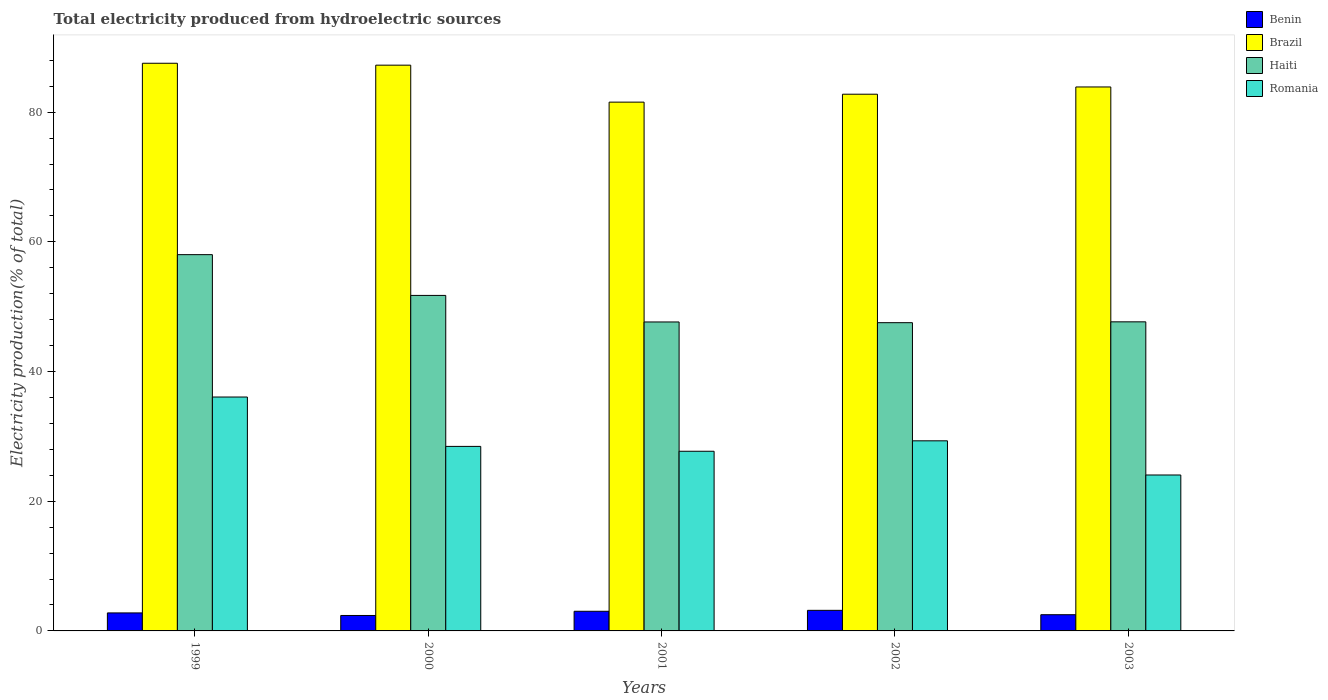How many different coloured bars are there?
Your answer should be very brief. 4. How many groups of bars are there?
Provide a succinct answer. 5. How many bars are there on the 1st tick from the left?
Ensure brevity in your answer.  4. How many bars are there on the 2nd tick from the right?
Offer a terse response. 4. What is the label of the 5th group of bars from the left?
Provide a succinct answer. 2003. In how many cases, is the number of bars for a given year not equal to the number of legend labels?
Provide a short and direct response. 0. What is the total electricity produced in Haiti in 1999?
Give a very brief answer. 58.02. Across all years, what is the maximum total electricity produced in Brazil?
Give a very brief answer. 87.54. Across all years, what is the minimum total electricity produced in Benin?
Keep it short and to the point. 2.38. In which year was the total electricity produced in Brazil maximum?
Keep it short and to the point. 1999. What is the total total electricity produced in Benin in the graph?
Offer a terse response. 13.86. What is the difference between the total electricity produced in Benin in 2001 and that in 2002?
Your answer should be very brief. -0.14. What is the difference between the total electricity produced in Brazil in 2003 and the total electricity produced in Romania in 1999?
Your answer should be very brief. 47.81. What is the average total electricity produced in Haiti per year?
Offer a terse response. 50.52. In the year 2001, what is the difference between the total electricity produced in Romania and total electricity produced in Haiti?
Offer a very short reply. -19.94. What is the ratio of the total electricity produced in Romania in 1999 to that in 2003?
Provide a succinct answer. 1.5. Is the total electricity produced in Benin in 2001 less than that in 2003?
Ensure brevity in your answer.  No. Is the difference between the total electricity produced in Romania in 2001 and 2002 greater than the difference between the total electricity produced in Haiti in 2001 and 2002?
Keep it short and to the point. No. What is the difference between the highest and the second highest total electricity produced in Romania?
Your answer should be compact. 6.75. What is the difference between the highest and the lowest total electricity produced in Brazil?
Provide a short and direct response. 5.99. In how many years, is the total electricity produced in Haiti greater than the average total electricity produced in Haiti taken over all years?
Give a very brief answer. 2. Is the sum of the total electricity produced in Benin in 1999 and 2002 greater than the maximum total electricity produced in Haiti across all years?
Your answer should be compact. No. What does the 2nd bar from the left in 2001 represents?
Make the answer very short. Brazil. What does the 1st bar from the right in 2002 represents?
Provide a succinct answer. Romania. Is it the case that in every year, the sum of the total electricity produced in Benin and total electricity produced in Haiti is greater than the total electricity produced in Romania?
Your answer should be very brief. Yes. How many years are there in the graph?
Your answer should be very brief. 5. Does the graph contain any zero values?
Make the answer very short. No. Where does the legend appear in the graph?
Offer a very short reply. Top right. How are the legend labels stacked?
Your answer should be compact. Vertical. What is the title of the graph?
Your answer should be compact. Total electricity produced from hydroelectric sources. What is the Electricity production(% of total) of Benin in 1999?
Give a very brief answer. 2.78. What is the Electricity production(% of total) in Brazil in 1999?
Your response must be concise. 87.54. What is the Electricity production(% of total) in Haiti in 1999?
Your answer should be very brief. 58.02. What is the Electricity production(% of total) in Romania in 1999?
Ensure brevity in your answer.  36.07. What is the Electricity production(% of total) in Benin in 2000?
Make the answer very short. 2.38. What is the Electricity production(% of total) of Brazil in 2000?
Ensure brevity in your answer.  87.24. What is the Electricity production(% of total) in Haiti in 2000?
Offer a terse response. 51.74. What is the Electricity production(% of total) in Romania in 2000?
Give a very brief answer. 28.46. What is the Electricity production(% of total) of Benin in 2001?
Make the answer very short. 3.03. What is the Electricity production(% of total) in Brazil in 2001?
Your answer should be very brief. 81.54. What is the Electricity production(% of total) of Haiti in 2001?
Offer a very short reply. 47.64. What is the Electricity production(% of total) of Romania in 2001?
Your answer should be very brief. 27.7. What is the Electricity production(% of total) of Benin in 2002?
Your answer should be very brief. 3.17. What is the Electricity production(% of total) of Brazil in 2002?
Your answer should be very brief. 82.76. What is the Electricity production(% of total) of Haiti in 2002?
Provide a short and direct response. 47.53. What is the Electricity production(% of total) in Romania in 2002?
Provide a succinct answer. 29.32. What is the Electricity production(% of total) in Benin in 2003?
Make the answer very short. 2.5. What is the Electricity production(% of total) in Brazil in 2003?
Your response must be concise. 83.88. What is the Electricity production(% of total) in Haiti in 2003?
Offer a terse response. 47.66. What is the Electricity production(% of total) of Romania in 2003?
Make the answer very short. 24.05. Across all years, what is the maximum Electricity production(% of total) of Benin?
Offer a terse response. 3.17. Across all years, what is the maximum Electricity production(% of total) of Brazil?
Ensure brevity in your answer.  87.54. Across all years, what is the maximum Electricity production(% of total) of Haiti?
Ensure brevity in your answer.  58.02. Across all years, what is the maximum Electricity production(% of total) of Romania?
Keep it short and to the point. 36.07. Across all years, what is the minimum Electricity production(% of total) of Benin?
Ensure brevity in your answer.  2.38. Across all years, what is the minimum Electricity production(% of total) of Brazil?
Keep it short and to the point. 81.54. Across all years, what is the minimum Electricity production(% of total) in Haiti?
Make the answer very short. 47.53. Across all years, what is the minimum Electricity production(% of total) in Romania?
Ensure brevity in your answer.  24.05. What is the total Electricity production(% of total) of Benin in the graph?
Offer a terse response. 13.86. What is the total Electricity production(% of total) in Brazil in the graph?
Your response must be concise. 422.97. What is the total Electricity production(% of total) in Haiti in the graph?
Provide a short and direct response. 252.6. What is the total Electricity production(% of total) of Romania in the graph?
Give a very brief answer. 145.59. What is the difference between the Electricity production(% of total) of Benin in 1999 and that in 2000?
Offer a terse response. 0.4. What is the difference between the Electricity production(% of total) in Brazil in 1999 and that in 2000?
Your answer should be compact. 0.29. What is the difference between the Electricity production(% of total) in Haiti in 1999 and that in 2000?
Offer a terse response. 6.29. What is the difference between the Electricity production(% of total) of Romania in 1999 and that in 2000?
Offer a very short reply. 7.61. What is the difference between the Electricity production(% of total) in Benin in 1999 and that in 2001?
Provide a short and direct response. -0.25. What is the difference between the Electricity production(% of total) in Brazil in 1999 and that in 2001?
Provide a short and direct response. 5.99. What is the difference between the Electricity production(% of total) of Haiti in 1999 and that in 2001?
Offer a very short reply. 10.38. What is the difference between the Electricity production(% of total) in Romania in 1999 and that in 2001?
Your answer should be compact. 8.36. What is the difference between the Electricity production(% of total) in Benin in 1999 and that in 2002?
Your answer should be compact. -0.4. What is the difference between the Electricity production(% of total) of Brazil in 1999 and that in 2002?
Your answer should be very brief. 4.77. What is the difference between the Electricity production(% of total) of Haiti in 1999 and that in 2002?
Make the answer very short. 10.49. What is the difference between the Electricity production(% of total) of Romania in 1999 and that in 2002?
Give a very brief answer. 6.75. What is the difference between the Electricity production(% of total) in Benin in 1999 and that in 2003?
Offer a terse response. 0.28. What is the difference between the Electricity production(% of total) of Brazil in 1999 and that in 2003?
Offer a terse response. 3.65. What is the difference between the Electricity production(% of total) of Haiti in 1999 and that in 2003?
Ensure brevity in your answer.  10.36. What is the difference between the Electricity production(% of total) in Romania in 1999 and that in 2003?
Provide a succinct answer. 12.02. What is the difference between the Electricity production(% of total) in Benin in 2000 and that in 2001?
Provide a succinct answer. -0.65. What is the difference between the Electricity production(% of total) of Brazil in 2000 and that in 2001?
Offer a very short reply. 5.7. What is the difference between the Electricity production(% of total) of Haiti in 2000 and that in 2001?
Give a very brief answer. 4.09. What is the difference between the Electricity production(% of total) in Romania in 2000 and that in 2001?
Keep it short and to the point. 0.75. What is the difference between the Electricity production(% of total) of Benin in 2000 and that in 2002?
Provide a short and direct response. -0.79. What is the difference between the Electricity production(% of total) of Brazil in 2000 and that in 2002?
Ensure brevity in your answer.  4.48. What is the difference between the Electricity production(% of total) of Haiti in 2000 and that in 2002?
Your response must be concise. 4.2. What is the difference between the Electricity production(% of total) of Romania in 2000 and that in 2002?
Your answer should be compact. -0.86. What is the difference between the Electricity production(% of total) of Benin in 2000 and that in 2003?
Your response must be concise. -0.12. What is the difference between the Electricity production(% of total) of Brazil in 2000 and that in 2003?
Ensure brevity in your answer.  3.36. What is the difference between the Electricity production(% of total) of Haiti in 2000 and that in 2003?
Offer a very short reply. 4.07. What is the difference between the Electricity production(% of total) in Romania in 2000 and that in 2003?
Give a very brief answer. 4.41. What is the difference between the Electricity production(% of total) in Benin in 2001 and that in 2002?
Your response must be concise. -0.14. What is the difference between the Electricity production(% of total) of Brazil in 2001 and that in 2002?
Your answer should be compact. -1.22. What is the difference between the Electricity production(% of total) of Romania in 2001 and that in 2002?
Your response must be concise. -1.61. What is the difference between the Electricity production(% of total) of Benin in 2001 and that in 2003?
Your answer should be compact. 0.53. What is the difference between the Electricity production(% of total) in Brazil in 2001 and that in 2003?
Make the answer very short. -2.34. What is the difference between the Electricity production(% of total) in Haiti in 2001 and that in 2003?
Keep it short and to the point. -0.02. What is the difference between the Electricity production(% of total) of Romania in 2001 and that in 2003?
Your response must be concise. 3.66. What is the difference between the Electricity production(% of total) in Benin in 2002 and that in 2003?
Your answer should be very brief. 0.67. What is the difference between the Electricity production(% of total) in Brazil in 2002 and that in 2003?
Offer a very short reply. -1.12. What is the difference between the Electricity production(% of total) in Haiti in 2002 and that in 2003?
Offer a terse response. -0.13. What is the difference between the Electricity production(% of total) of Romania in 2002 and that in 2003?
Offer a very short reply. 5.27. What is the difference between the Electricity production(% of total) in Benin in 1999 and the Electricity production(% of total) in Brazil in 2000?
Provide a short and direct response. -84.47. What is the difference between the Electricity production(% of total) of Benin in 1999 and the Electricity production(% of total) of Haiti in 2000?
Keep it short and to the point. -48.96. What is the difference between the Electricity production(% of total) in Benin in 1999 and the Electricity production(% of total) in Romania in 2000?
Your response must be concise. -25.68. What is the difference between the Electricity production(% of total) in Brazil in 1999 and the Electricity production(% of total) in Haiti in 2000?
Give a very brief answer. 35.8. What is the difference between the Electricity production(% of total) of Brazil in 1999 and the Electricity production(% of total) of Romania in 2000?
Keep it short and to the point. 59.08. What is the difference between the Electricity production(% of total) of Haiti in 1999 and the Electricity production(% of total) of Romania in 2000?
Your response must be concise. 29.57. What is the difference between the Electricity production(% of total) of Benin in 1999 and the Electricity production(% of total) of Brazil in 2001?
Keep it short and to the point. -78.77. What is the difference between the Electricity production(% of total) of Benin in 1999 and the Electricity production(% of total) of Haiti in 2001?
Offer a terse response. -44.87. What is the difference between the Electricity production(% of total) in Benin in 1999 and the Electricity production(% of total) in Romania in 2001?
Offer a very short reply. -24.93. What is the difference between the Electricity production(% of total) of Brazil in 1999 and the Electricity production(% of total) of Haiti in 2001?
Provide a succinct answer. 39.89. What is the difference between the Electricity production(% of total) of Brazil in 1999 and the Electricity production(% of total) of Romania in 2001?
Keep it short and to the point. 59.83. What is the difference between the Electricity production(% of total) in Haiti in 1999 and the Electricity production(% of total) in Romania in 2001?
Provide a short and direct response. 30.32. What is the difference between the Electricity production(% of total) of Benin in 1999 and the Electricity production(% of total) of Brazil in 2002?
Offer a terse response. -79.99. What is the difference between the Electricity production(% of total) in Benin in 1999 and the Electricity production(% of total) in Haiti in 2002?
Give a very brief answer. -44.75. What is the difference between the Electricity production(% of total) in Benin in 1999 and the Electricity production(% of total) in Romania in 2002?
Offer a very short reply. -26.54. What is the difference between the Electricity production(% of total) of Brazil in 1999 and the Electricity production(% of total) of Haiti in 2002?
Make the answer very short. 40. What is the difference between the Electricity production(% of total) in Brazil in 1999 and the Electricity production(% of total) in Romania in 2002?
Offer a very short reply. 58.22. What is the difference between the Electricity production(% of total) of Haiti in 1999 and the Electricity production(% of total) of Romania in 2002?
Your response must be concise. 28.71. What is the difference between the Electricity production(% of total) of Benin in 1999 and the Electricity production(% of total) of Brazil in 2003?
Give a very brief answer. -81.1. What is the difference between the Electricity production(% of total) of Benin in 1999 and the Electricity production(% of total) of Haiti in 2003?
Give a very brief answer. -44.89. What is the difference between the Electricity production(% of total) in Benin in 1999 and the Electricity production(% of total) in Romania in 2003?
Your answer should be compact. -21.27. What is the difference between the Electricity production(% of total) in Brazil in 1999 and the Electricity production(% of total) in Haiti in 2003?
Your answer should be compact. 39.87. What is the difference between the Electricity production(% of total) in Brazil in 1999 and the Electricity production(% of total) in Romania in 2003?
Your answer should be very brief. 63.49. What is the difference between the Electricity production(% of total) in Haiti in 1999 and the Electricity production(% of total) in Romania in 2003?
Give a very brief answer. 33.98. What is the difference between the Electricity production(% of total) in Benin in 2000 and the Electricity production(% of total) in Brazil in 2001?
Provide a succinct answer. -79.16. What is the difference between the Electricity production(% of total) in Benin in 2000 and the Electricity production(% of total) in Haiti in 2001?
Offer a very short reply. -45.26. What is the difference between the Electricity production(% of total) in Benin in 2000 and the Electricity production(% of total) in Romania in 2001?
Offer a very short reply. -25.32. What is the difference between the Electricity production(% of total) in Brazil in 2000 and the Electricity production(% of total) in Haiti in 2001?
Offer a very short reply. 39.6. What is the difference between the Electricity production(% of total) of Brazil in 2000 and the Electricity production(% of total) of Romania in 2001?
Your answer should be compact. 59.54. What is the difference between the Electricity production(% of total) in Haiti in 2000 and the Electricity production(% of total) in Romania in 2001?
Your answer should be compact. 24.03. What is the difference between the Electricity production(% of total) in Benin in 2000 and the Electricity production(% of total) in Brazil in 2002?
Give a very brief answer. -80.38. What is the difference between the Electricity production(% of total) in Benin in 2000 and the Electricity production(% of total) in Haiti in 2002?
Offer a very short reply. -45.15. What is the difference between the Electricity production(% of total) in Benin in 2000 and the Electricity production(% of total) in Romania in 2002?
Keep it short and to the point. -26.93. What is the difference between the Electricity production(% of total) in Brazil in 2000 and the Electricity production(% of total) in Haiti in 2002?
Make the answer very short. 39.71. What is the difference between the Electricity production(% of total) of Brazil in 2000 and the Electricity production(% of total) of Romania in 2002?
Offer a terse response. 57.93. What is the difference between the Electricity production(% of total) of Haiti in 2000 and the Electricity production(% of total) of Romania in 2002?
Keep it short and to the point. 22.42. What is the difference between the Electricity production(% of total) in Benin in 2000 and the Electricity production(% of total) in Brazil in 2003?
Offer a very short reply. -81.5. What is the difference between the Electricity production(% of total) in Benin in 2000 and the Electricity production(% of total) in Haiti in 2003?
Offer a terse response. -45.28. What is the difference between the Electricity production(% of total) in Benin in 2000 and the Electricity production(% of total) in Romania in 2003?
Ensure brevity in your answer.  -21.67. What is the difference between the Electricity production(% of total) of Brazil in 2000 and the Electricity production(% of total) of Haiti in 2003?
Your response must be concise. 39.58. What is the difference between the Electricity production(% of total) in Brazil in 2000 and the Electricity production(% of total) in Romania in 2003?
Provide a succinct answer. 63.2. What is the difference between the Electricity production(% of total) of Haiti in 2000 and the Electricity production(% of total) of Romania in 2003?
Offer a terse response. 27.69. What is the difference between the Electricity production(% of total) of Benin in 2001 and the Electricity production(% of total) of Brazil in 2002?
Ensure brevity in your answer.  -79.73. What is the difference between the Electricity production(% of total) in Benin in 2001 and the Electricity production(% of total) in Haiti in 2002?
Offer a terse response. -44.5. What is the difference between the Electricity production(% of total) of Benin in 2001 and the Electricity production(% of total) of Romania in 2002?
Give a very brief answer. -26.29. What is the difference between the Electricity production(% of total) in Brazil in 2001 and the Electricity production(% of total) in Haiti in 2002?
Offer a very short reply. 34.01. What is the difference between the Electricity production(% of total) in Brazil in 2001 and the Electricity production(% of total) in Romania in 2002?
Provide a succinct answer. 52.23. What is the difference between the Electricity production(% of total) in Haiti in 2001 and the Electricity production(% of total) in Romania in 2002?
Your response must be concise. 18.33. What is the difference between the Electricity production(% of total) in Benin in 2001 and the Electricity production(% of total) in Brazil in 2003?
Give a very brief answer. -80.85. What is the difference between the Electricity production(% of total) of Benin in 2001 and the Electricity production(% of total) of Haiti in 2003?
Give a very brief answer. -44.63. What is the difference between the Electricity production(% of total) in Benin in 2001 and the Electricity production(% of total) in Romania in 2003?
Make the answer very short. -21.02. What is the difference between the Electricity production(% of total) of Brazil in 2001 and the Electricity production(% of total) of Haiti in 2003?
Your response must be concise. 33.88. What is the difference between the Electricity production(% of total) in Brazil in 2001 and the Electricity production(% of total) in Romania in 2003?
Your response must be concise. 57.5. What is the difference between the Electricity production(% of total) of Haiti in 2001 and the Electricity production(% of total) of Romania in 2003?
Provide a short and direct response. 23.6. What is the difference between the Electricity production(% of total) in Benin in 2002 and the Electricity production(% of total) in Brazil in 2003?
Give a very brief answer. -80.71. What is the difference between the Electricity production(% of total) of Benin in 2002 and the Electricity production(% of total) of Haiti in 2003?
Keep it short and to the point. -44.49. What is the difference between the Electricity production(% of total) in Benin in 2002 and the Electricity production(% of total) in Romania in 2003?
Provide a succinct answer. -20.87. What is the difference between the Electricity production(% of total) in Brazil in 2002 and the Electricity production(% of total) in Haiti in 2003?
Offer a very short reply. 35.1. What is the difference between the Electricity production(% of total) of Brazil in 2002 and the Electricity production(% of total) of Romania in 2003?
Offer a very short reply. 58.72. What is the difference between the Electricity production(% of total) in Haiti in 2002 and the Electricity production(% of total) in Romania in 2003?
Make the answer very short. 23.49. What is the average Electricity production(% of total) in Benin per year?
Your answer should be compact. 2.77. What is the average Electricity production(% of total) in Brazil per year?
Provide a short and direct response. 84.59. What is the average Electricity production(% of total) of Haiti per year?
Ensure brevity in your answer.  50.52. What is the average Electricity production(% of total) in Romania per year?
Provide a succinct answer. 29.12. In the year 1999, what is the difference between the Electricity production(% of total) of Benin and Electricity production(% of total) of Brazil?
Make the answer very short. -84.76. In the year 1999, what is the difference between the Electricity production(% of total) of Benin and Electricity production(% of total) of Haiti?
Your response must be concise. -55.25. In the year 1999, what is the difference between the Electricity production(% of total) of Benin and Electricity production(% of total) of Romania?
Offer a terse response. -33.29. In the year 1999, what is the difference between the Electricity production(% of total) in Brazil and Electricity production(% of total) in Haiti?
Your answer should be very brief. 29.51. In the year 1999, what is the difference between the Electricity production(% of total) in Brazil and Electricity production(% of total) in Romania?
Offer a very short reply. 51.47. In the year 1999, what is the difference between the Electricity production(% of total) in Haiti and Electricity production(% of total) in Romania?
Your answer should be compact. 21.96. In the year 2000, what is the difference between the Electricity production(% of total) in Benin and Electricity production(% of total) in Brazil?
Ensure brevity in your answer.  -84.86. In the year 2000, what is the difference between the Electricity production(% of total) in Benin and Electricity production(% of total) in Haiti?
Your response must be concise. -49.36. In the year 2000, what is the difference between the Electricity production(% of total) in Benin and Electricity production(% of total) in Romania?
Provide a short and direct response. -26.07. In the year 2000, what is the difference between the Electricity production(% of total) in Brazil and Electricity production(% of total) in Haiti?
Offer a terse response. 35.51. In the year 2000, what is the difference between the Electricity production(% of total) of Brazil and Electricity production(% of total) of Romania?
Provide a short and direct response. 58.79. In the year 2000, what is the difference between the Electricity production(% of total) of Haiti and Electricity production(% of total) of Romania?
Ensure brevity in your answer.  23.28. In the year 2001, what is the difference between the Electricity production(% of total) of Benin and Electricity production(% of total) of Brazil?
Your response must be concise. -78.51. In the year 2001, what is the difference between the Electricity production(% of total) of Benin and Electricity production(% of total) of Haiti?
Ensure brevity in your answer.  -44.61. In the year 2001, what is the difference between the Electricity production(% of total) in Benin and Electricity production(% of total) in Romania?
Ensure brevity in your answer.  -24.67. In the year 2001, what is the difference between the Electricity production(% of total) in Brazil and Electricity production(% of total) in Haiti?
Provide a short and direct response. 33.9. In the year 2001, what is the difference between the Electricity production(% of total) in Brazil and Electricity production(% of total) in Romania?
Your answer should be very brief. 53.84. In the year 2001, what is the difference between the Electricity production(% of total) of Haiti and Electricity production(% of total) of Romania?
Provide a succinct answer. 19.94. In the year 2002, what is the difference between the Electricity production(% of total) of Benin and Electricity production(% of total) of Brazil?
Provide a short and direct response. -79.59. In the year 2002, what is the difference between the Electricity production(% of total) in Benin and Electricity production(% of total) in Haiti?
Make the answer very short. -44.36. In the year 2002, what is the difference between the Electricity production(% of total) in Benin and Electricity production(% of total) in Romania?
Give a very brief answer. -26.14. In the year 2002, what is the difference between the Electricity production(% of total) in Brazil and Electricity production(% of total) in Haiti?
Keep it short and to the point. 35.23. In the year 2002, what is the difference between the Electricity production(% of total) of Brazil and Electricity production(% of total) of Romania?
Your answer should be compact. 53.45. In the year 2002, what is the difference between the Electricity production(% of total) of Haiti and Electricity production(% of total) of Romania?
Your answer should be very brief. 18.22. In the year 2003, what is the difference between the Electricity production(% of total) of Benin and Electricity production(% of total) of Brazil?
Your response must be concise. -81.38. In the year 2003, what is the difference between the Electricity production(% of total) in Benin and Electricity production(% of total) in Haiti?
Make the answer very short. -45.16. In the year 2003, what is the difference between the Electricity production(% of total) in Benin and Electricity production(% of total) in Romania?
Provide a succinct answer. -21.55. In the year 2003, what is the difference between the Electricity production(% of total) in Brazil and Electricity production(% of total) in Haiti?
Your answer should be compact. 36.22. In the year 2003, what is the difference between the Electricity production(% of total) of Brazil and Electricity production(% of total) of Romania?
Your answer should be compact. 59.84. In the year 2003, what is the difference between the Electricity production(% of total) in Haiti and Electricity production(% of total) in Romania?
Offer a very short reply. 23.62. What is the ratio of the Electricity production(% of total) of Haiti in 1999 to that in 2000?
Ensure brevity in your answer.  1.12. What is the ratio of the Electricity production(% of total) of Romania in 1999 to that in 2000?
Your answer should be very brief. 1.27. What is the ratio of the Electricity production(% of total) of Brazil in 1999 to that in 2001?
Provide a succinct answer. 1.07. What is the ratio of the Electricity production(% of total) in Haiti in 1999 to that in 2001?
Provide a succinct answer. 1.22. What is the ratio of the Electricity production(% of total) of Romania in 1999 to that in 2001?
Provide a short and direct response. 1.3. What is the ratio of the Electricity production(% of total) in Brazil in 1999 to that in 2002?
Provide a short and direct response. 1.06. What is the ratio of the Electricity production(% of total) in Haiti in 1999 to that in 2002?
Ensure brevity in your answer.  1.22. What is the ratio of the Electricity production(% of total) of Romania in 1999 to that in 2002?
Provide a succinct answer. 1.23. What is the ratio of the Electricity production(% of total) in Benin in 1999 to that in 2003?
Provide a succinct answer. 1.11. What is the ratio of the Electricity production(% of total) of Brazil in 1999 to that in 2003?
Your answer should be very brief. 1.04. What is the ratio of the Electricity production(% of total) of Haiti in 1999 to that in 2003?
Offer a very short reply. 1.22. What is the ratio of the Electricity production(% of total) of Romania in 1999 to that in 2003?
Provide a short and direct response. 1.5. What is the ratio of the Electricity production(% of total) of Benin in 2000 to that in 2001?
Your answer should be compact. 0.79. What is the ratio of the Electricity production(% of total) in Brazil in 2000 to that in 2001?
Your answer should be very brief. 1.07. What is the ratio of the Electricity production(% of total) of Haiti in 2000 to that in 2001?
Offer a terse response. 1.09. What is the ratio of the Electricity production(% of total) in Romania in 2000 to that in 2001?
Your response must be concise. 1.03. What is the ratio of the Electricity production(% of total) in Benin in 2000 to that in 2002?
Your answer should be compact. 0.75. What is the ratio of the Electricity production(% of total) of Brazil in 2000 to that in 2002?
Make the answer very short. 1.05. What is the ratio of the Electricity production(% of total) in Haiti in 2000 to that in 2002?
Provide a short and direct response. 1.09. What is the ratio of the Electricity production(% of total) in Romania in 2000 to that in 2002?
Offer a very short reply. 0.97. What is the ratio of the Electricity production(% of total) in Brazil in 2000 to that in 2003?
Make the answer very short. 1.04. What is the ratio of the Electricity production(% of total) in Haiti in 2000 to that in 2003?
Your answer should be very brief. 1.09. What is the ratio of the Electricity production(% of total) of Romania in 2000 to that in 2003?
Provide a succinct answer. 1.18. What is the ratio of the Electricity production(% of total) in Benin in 2001 to that in 2002?
Ensure brevity in your answer.  0.95. What is the ratio of the Electricity production(% of total) of Brazil in 2001 to that in 2002?
Keep it short and to the point. 0.99. What is the ratio of the Electricity production(% of total) in Haiti in 2001 to that in 2002?
Your answer should be compact. 1. What is the ratio of the Electricity production(% of total) in Romania in 2001 to that in 2002?
Your answer should be very brief. 0.94. What is the ratio of the Electricity production(% of total) in Benin in 2001 to that in 2003?
Give a very brief answer. 1.21. What is the ratio of the Electricity production(% of total) of Brazil in 2001 to that in 2003?
Ensure brevity in your answer.  0.97. What is the ratio of the Electricity production(% of total) in Romania in 2001 to that in 2003?
Your answer should be compact. 1.15. What is the ratio of the Electricity production(% of total) of Benin in 2002 to that in 2003?
Offer a terse response. 1.27. What is the ratio of the Electricity production(% of total) of Brazil in 2002 to that in 2003?
Ensure brevity in your answer.  0.99. What is the ratio of the Electricity production(% of total) in Haiti in 2002 to that in 2003?
Your answer should be very brief. 1. What is the ratio of the Electricity production(% of total) of Romania in 2002 to that in 2003?
Your answer should be very brief. 1.22. What is the difference between the highest and the second highest Electricity production(% of total) in Benin?
Your answer should be very brief. 0.14. What is the difference between the highest and the second highest Electricity production(% of total) in Brazil?
Provide a succinct answer. 0.29. What is the difference between the highest and the second highest Electricity production(% of total) in Haiti?
Ensure brevity in your answer.  6.29. What is the difference between the highest and the second highest Electricity production(% of total) in Romania?
Provide a short and direct response. 6.75. What is the difference between the highest and the lowest Electricity production(% of total) of Benin?
Ensure brevity in your answer.  0.79. What is the difference between the highest and the lowest Electricity production(% of total) of Brazil?
Give a very brief answer. 5.99. What is the difference between the highest and the lowest Electricity production(% of total) in Haiti?
Offer a terse response. 10.49. What is the difference between the highest and the lowest Electricity production(% of total) in Romania?
Offer a terse response. 12.02. 